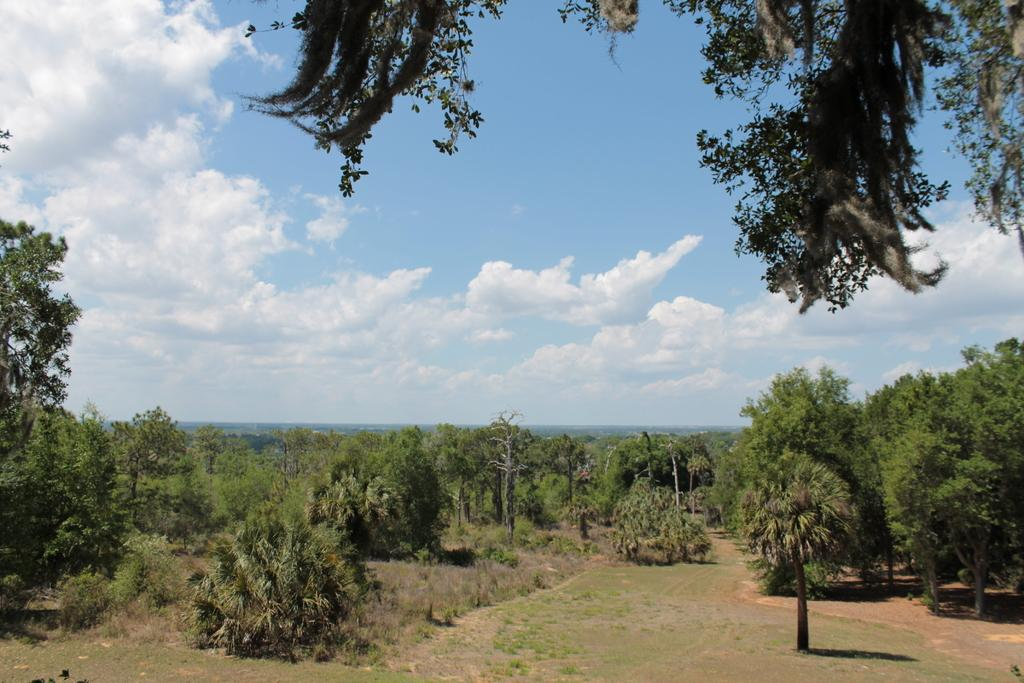What type of vegetation can be seen at the bottom of the image? There are trees in the bottom of the image. What is the condition of the sky in the background of the image? There is a cloudy sky in the background of the image. What part of the tree is visible at the top of the image? There are leaves of a tree visible on the top of the image. What type of loaf is being baked in the image? There is no loaf or baking activity present in the image. Can you describe the mist in the image? There is no mist present in the image; it features trees and a cloudy sky. 